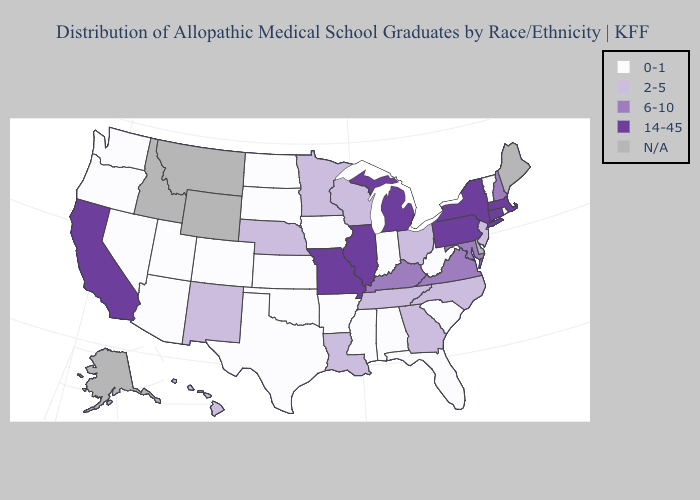Name the states that have a value in the range 0-1?
Keep it brief. Alabama, Arizona, Arkansas, Colorado, Florida, Indiana, Iowa, Kansas, Mississippi, Nevada, North Dakota, Oklahoma, Oregon, Rhode Island, South Carolina, South Dakota, Texas, Utah, Vermont, Washington, West Virginia. Which states have the lowest value in the Northeast?
Write a very short answer. Rhode Island, Vermont. Does Michigan have the highest value in the USA?
Short answer required. Yes. Which states have the lowest value in the West?
Quick response, please. Arizona, Colorado, Nevada, Oregon, Utah, Washington. Does Hawaii have the highest value in the West?
Give a very brief answer. No. Does Pennsylvania have the highest value in the Northeast?
Short answer required. Yes. Name the states that have a value in the range 2-5?
Concise answer only. Georgia, Hawaii, Louisiana, Minnesota, Nebraska, New Jersey, New Mexico, North Carolina, Ohio, Tennessee, Wisconsin. Does the first symbol in the legend represent the smallest category?
Quick response, please. Yes. Does the map have missing data?
Give a very brief answer. Yes. Does Michigan have the highest value in the MidWest?
Give a very brief answer. Yes. Name the states that have a value in the range 6-10?
Give a very brief answer. Kentucky, Maryland, New Hampshire, Virginia. What is the value of North Carolina?
Quick response, please. 2-5. Name the states that have a value in the range 14-45?
Keep it brief. California, Connecticut, Illinois, Massachusetts, Michigan, Missouri, New York, Pennsylvania. What is the value of Iowa?
Answer briefly. 0-1. 